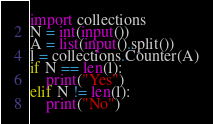Convert code to text. <code><loc_0><loc_0><loc_500><loc_500><_Python_>import collections
N = int(input())
A = list(input().split())
l = collections.Counter(A)
if N == len(l):
    print("Yes")
elif N != len(l):
    print("No")</code> 